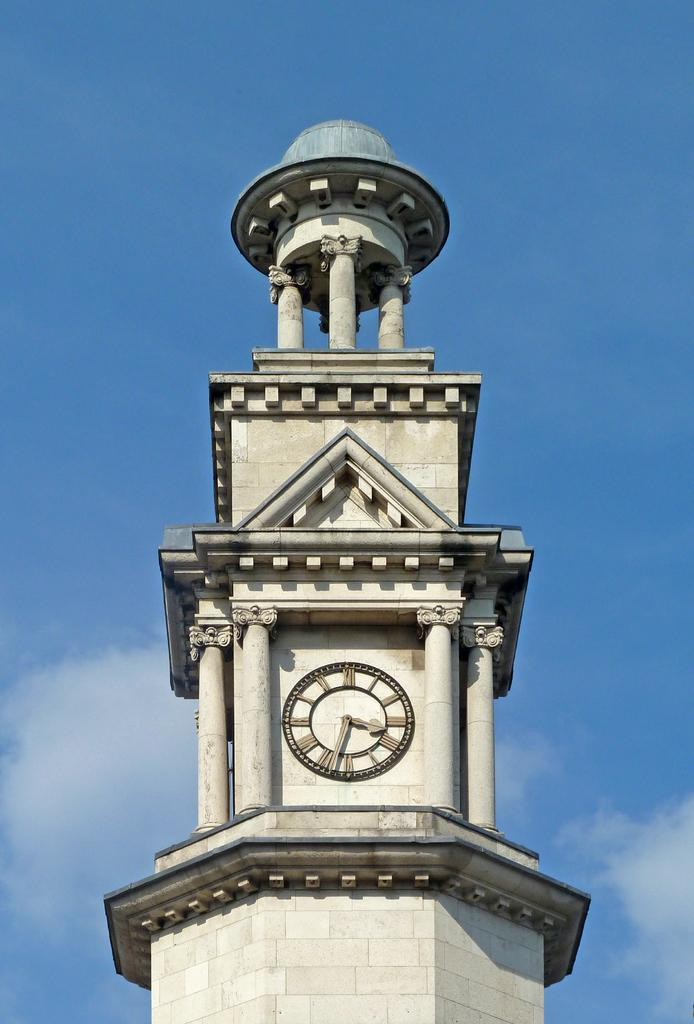Provide a one-sentence caption for the provided image. A clock tower with the hands at 3:33 on the face. 